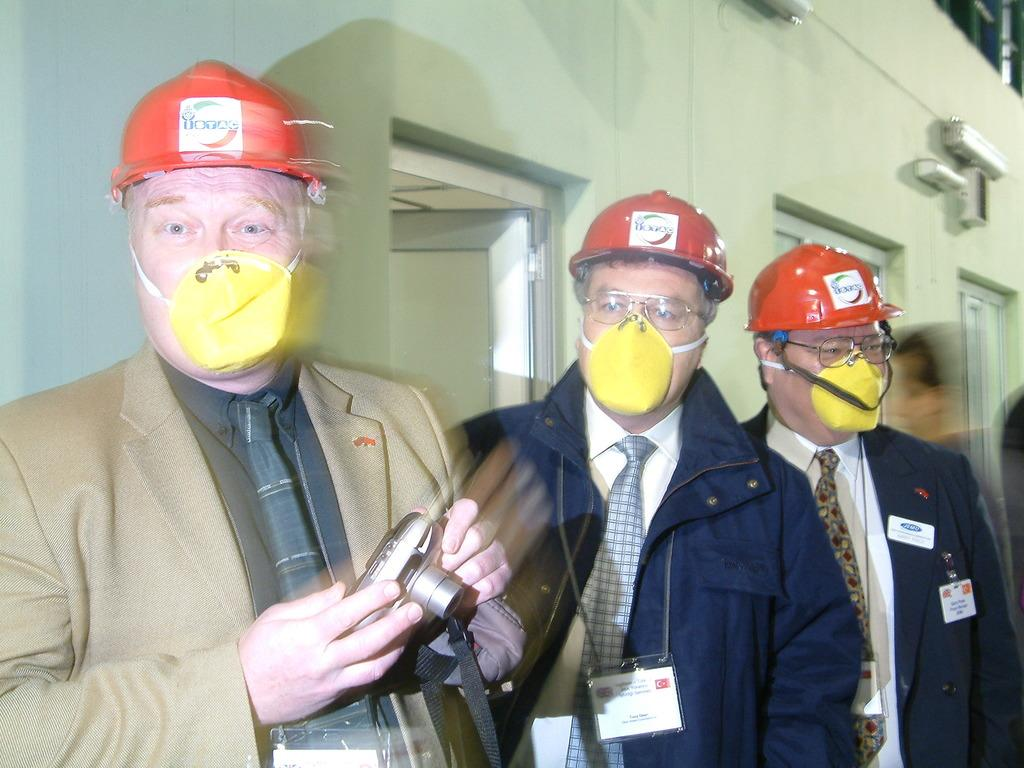How many people are in the image? There are three men standing in the image. What are the men wearing on their faces? The men are wearing masks on their faces. What else are the men wearing? The men are wearing helmets. What is the first person holding in his hand? The first person is holding a camera in his hand. What can be seen on the wall in the background of the image? There are doors on the wall in the background of the image. What type of butter is being rubbed on the sidewalk in the image? There is no butter or sidewalk present in the image. What is the men's reaction to the butter on the sidewalk? There is no butter or sidewalk present in the image, so it is not possible to determine the men's reaction. 